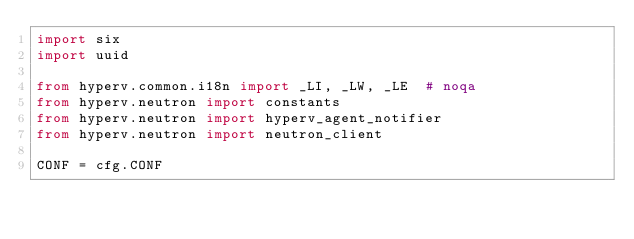Convert code to text. <code><loc_0><loc_0><loc_500><loc_500><_Python_>import six
import uuid

from hyperv.common.i18n import _LI, _LW, _LE  # noqa
from hyperv.neutron import constants
from hyperv.neutron import hyperv_agent_notifier
from hyperv.neutron import neutron_client

CONF = cfg.CONF</code> 